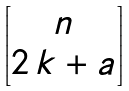<formula> <loc_0><loc_0><loc_500><loc_500>\begin{bmatrix} n \\ 2 \, k + a \end{bmatrix}</formula> 